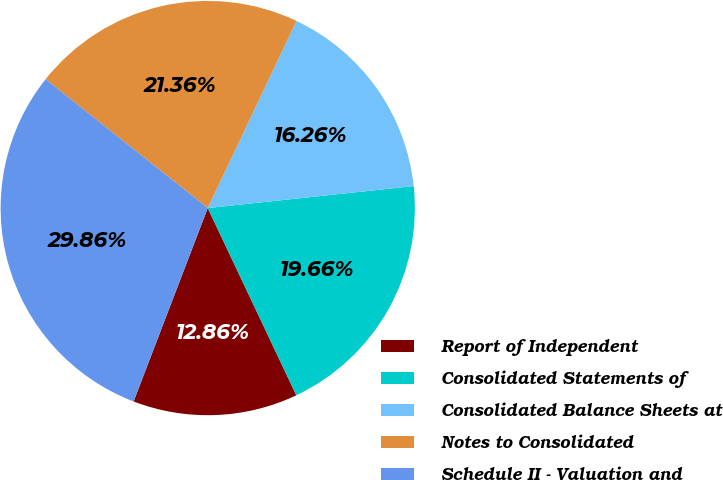Convert chart to OTSL. <chart><loc_0><loc_0><loc_500><loc_500><pie_chart><fcel>Report of Independent<fcel>Consolidated Statements of<fcel>Consolidated Balance Sheets at<fcel>Notes to Consolidated<fcel>Schedule II - Valuation and<nl><fcel>12.86%<fcel>19.66%<fcel>16.26%<fcel>21.36%<fcel>29.86%<nl></chart> 